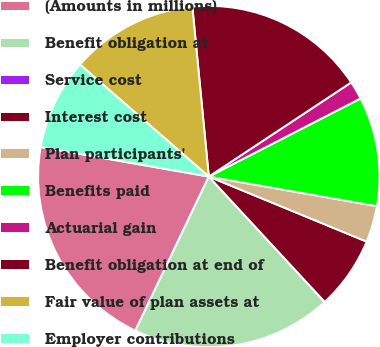Convert chart. <chart><loc_0><loc_0><loc_500><loc_500><pie_chart><fcel>(Amounts in millions)<fcel>Benefit obligation at<fcel>Service cost<fcel>Interest cost<fcel>Plan participants'<fcel>Benefits paid<fcel>Actuarial gain<fcel>Benefit obligation at end of<fcel>Fair value of plan assets at<fcel>Employer contributions<nl><fcel>20.69%<fcel>18.96%<fcel>0.0%<fcel>6.9%<fcel>3.45%<fcel>10.34%<fcel>1.73%<fcel>17.24%<fcel>12.07%<fcel>8.62%<nl></chart> 